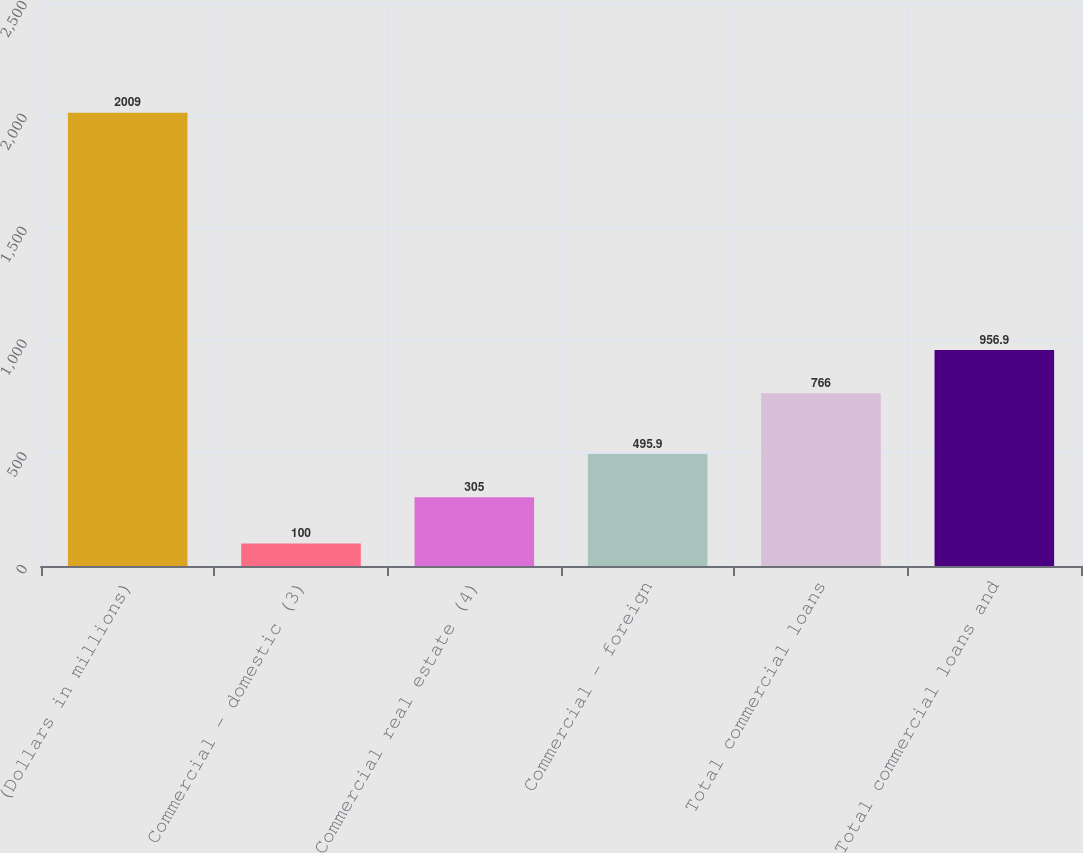Convert chart. <chart><loc_0><loc_0><loc_500><loc_500><bar_chart><fcel>(Dollars in millions)<fcel>Commercial - domestic (3)<fcel>Commercial real estate (4)<fcel>Commercial - foreign<fcel>Total commercial loans<fcel>Total commercial loans and<nl><fcel>2009<fcel>100<fcel>305<fcel>495.9<fcel>766<fcel>956.9<nl></chart> 